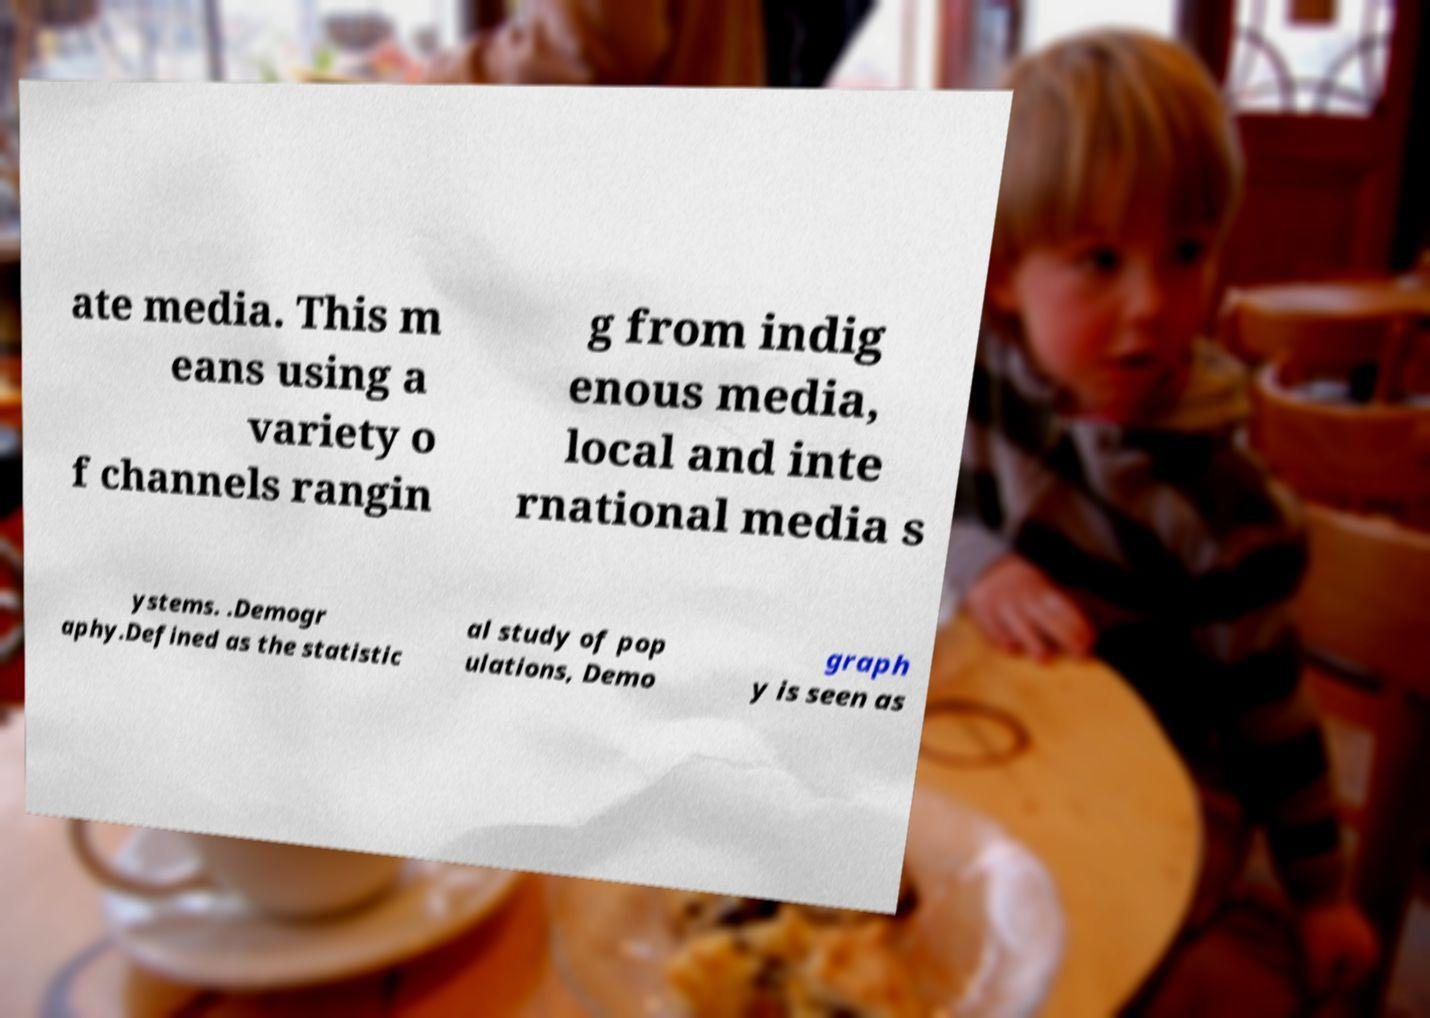Please read and relay the text visible in this image. What does it say? ate media. This m eans using a variety o f channels rangin g from indig enous media, local and inte rnational media s ystems. .Demogr aphy.Defined as the statistic al study of pop ulations, Demo graph y is seen as 